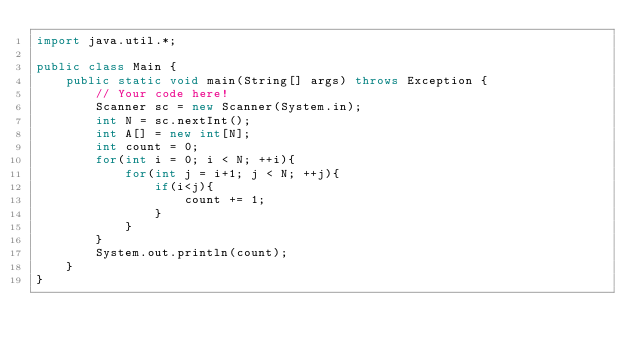Convert code to text. <code><loc_0><loc_0><loc_500><loc_500><_Java_>import java.util.*;

public class Main {
    public static void main(String[] args) throws Exception {
        // Your code here!
        Scanner sc = new Scanner(System.in);
        int N = sc.nextInt();
        int A[] = new int[N];
        int count = 0;
        for(int i = 0; i < N; ++i){
            for(int j = i+1; j < N; ++j){
                if(i<j){
                    count += 1;
                }
            }
        }
        System.out.println(count);
    }
}
</code> 